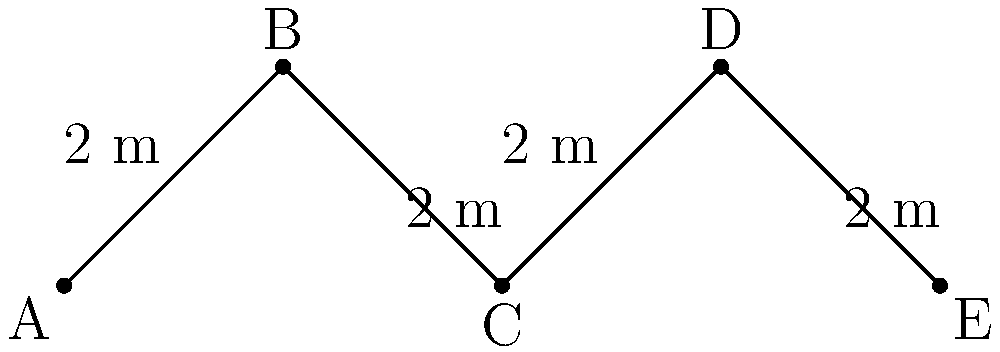In your research on African tribal fence designs, you've encountered a zigzag pattern used for perimeter fencing. The pattern consists of 4 identical segments, each 2 meters long, as shown in the diagram. What is the total perimeter of this fence design if it were to enclose a rectangular area with 5 such zigzag units on each of the longer sides and 3 units on each shorter side? Let's approach this step-by-step:

1) First, we need to calculate the length of one zigzag unit:
   One unit consists of 4 segments, each 2 meters long.
   Length of one unit = $4 \times 2 = 8$ meters

2) Now, let's consider the perimeter:
   - Longer sides: 5 units each
   - Shorter sides: 3 units each

3) Calculate the length of the longer sides:
   Length of one longer side = $5 \times 8 = 40$ meters

4) Calculate the length of the shorter sides:
   Length of one shorter side = $3 \times 8 = 24$ meters

5) The perimeter consists of 2 longer sides and 2 shorter sides:
   Perimeter = $2(\text{longer side}) + 2(\text{shorter side})$
              = $2(40) + 2(24)$
              = $80 + 48$
              = $128$ meters

Therefore, the total perimeter of the fence design is 128 meters.
Answer: 128 meters 